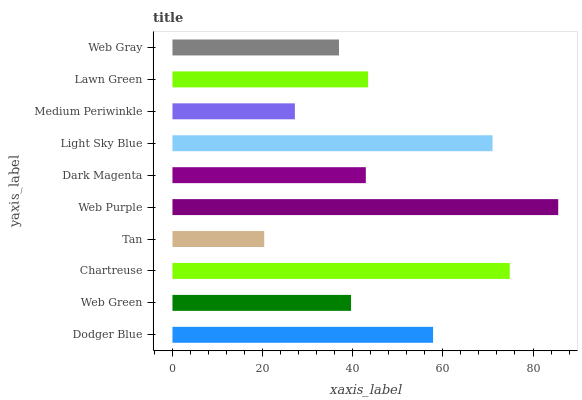Is Tan the minimum?
Answer yes or no. Yes. Is Web Purple the maximum?
Answer yes or no. Yes. Is Web Green the minimum?
Answer yes or no. No. Is Web Green the maximum?
Answer yes or no. No. Is Dodger Blue greater than Web Green?
Answer yes or no. Yes. Is Web Green less than Dodger Blue?
Answer yes or no. Yes. Is Web Green greater than Dodger Blue?
Answer yes or no. No. Is Dodger Blue less than Web Green?
Answer yes or no. No. Is Lawn Green the high median?
Answer yes or no. Yes. Is Dark Magenta the low median?
Answer yes or no. Yes. Is Medium Periwinkle the high median?
Answer yes or no. No. Is Web Purple the low median?
Answer yes or no. No. 